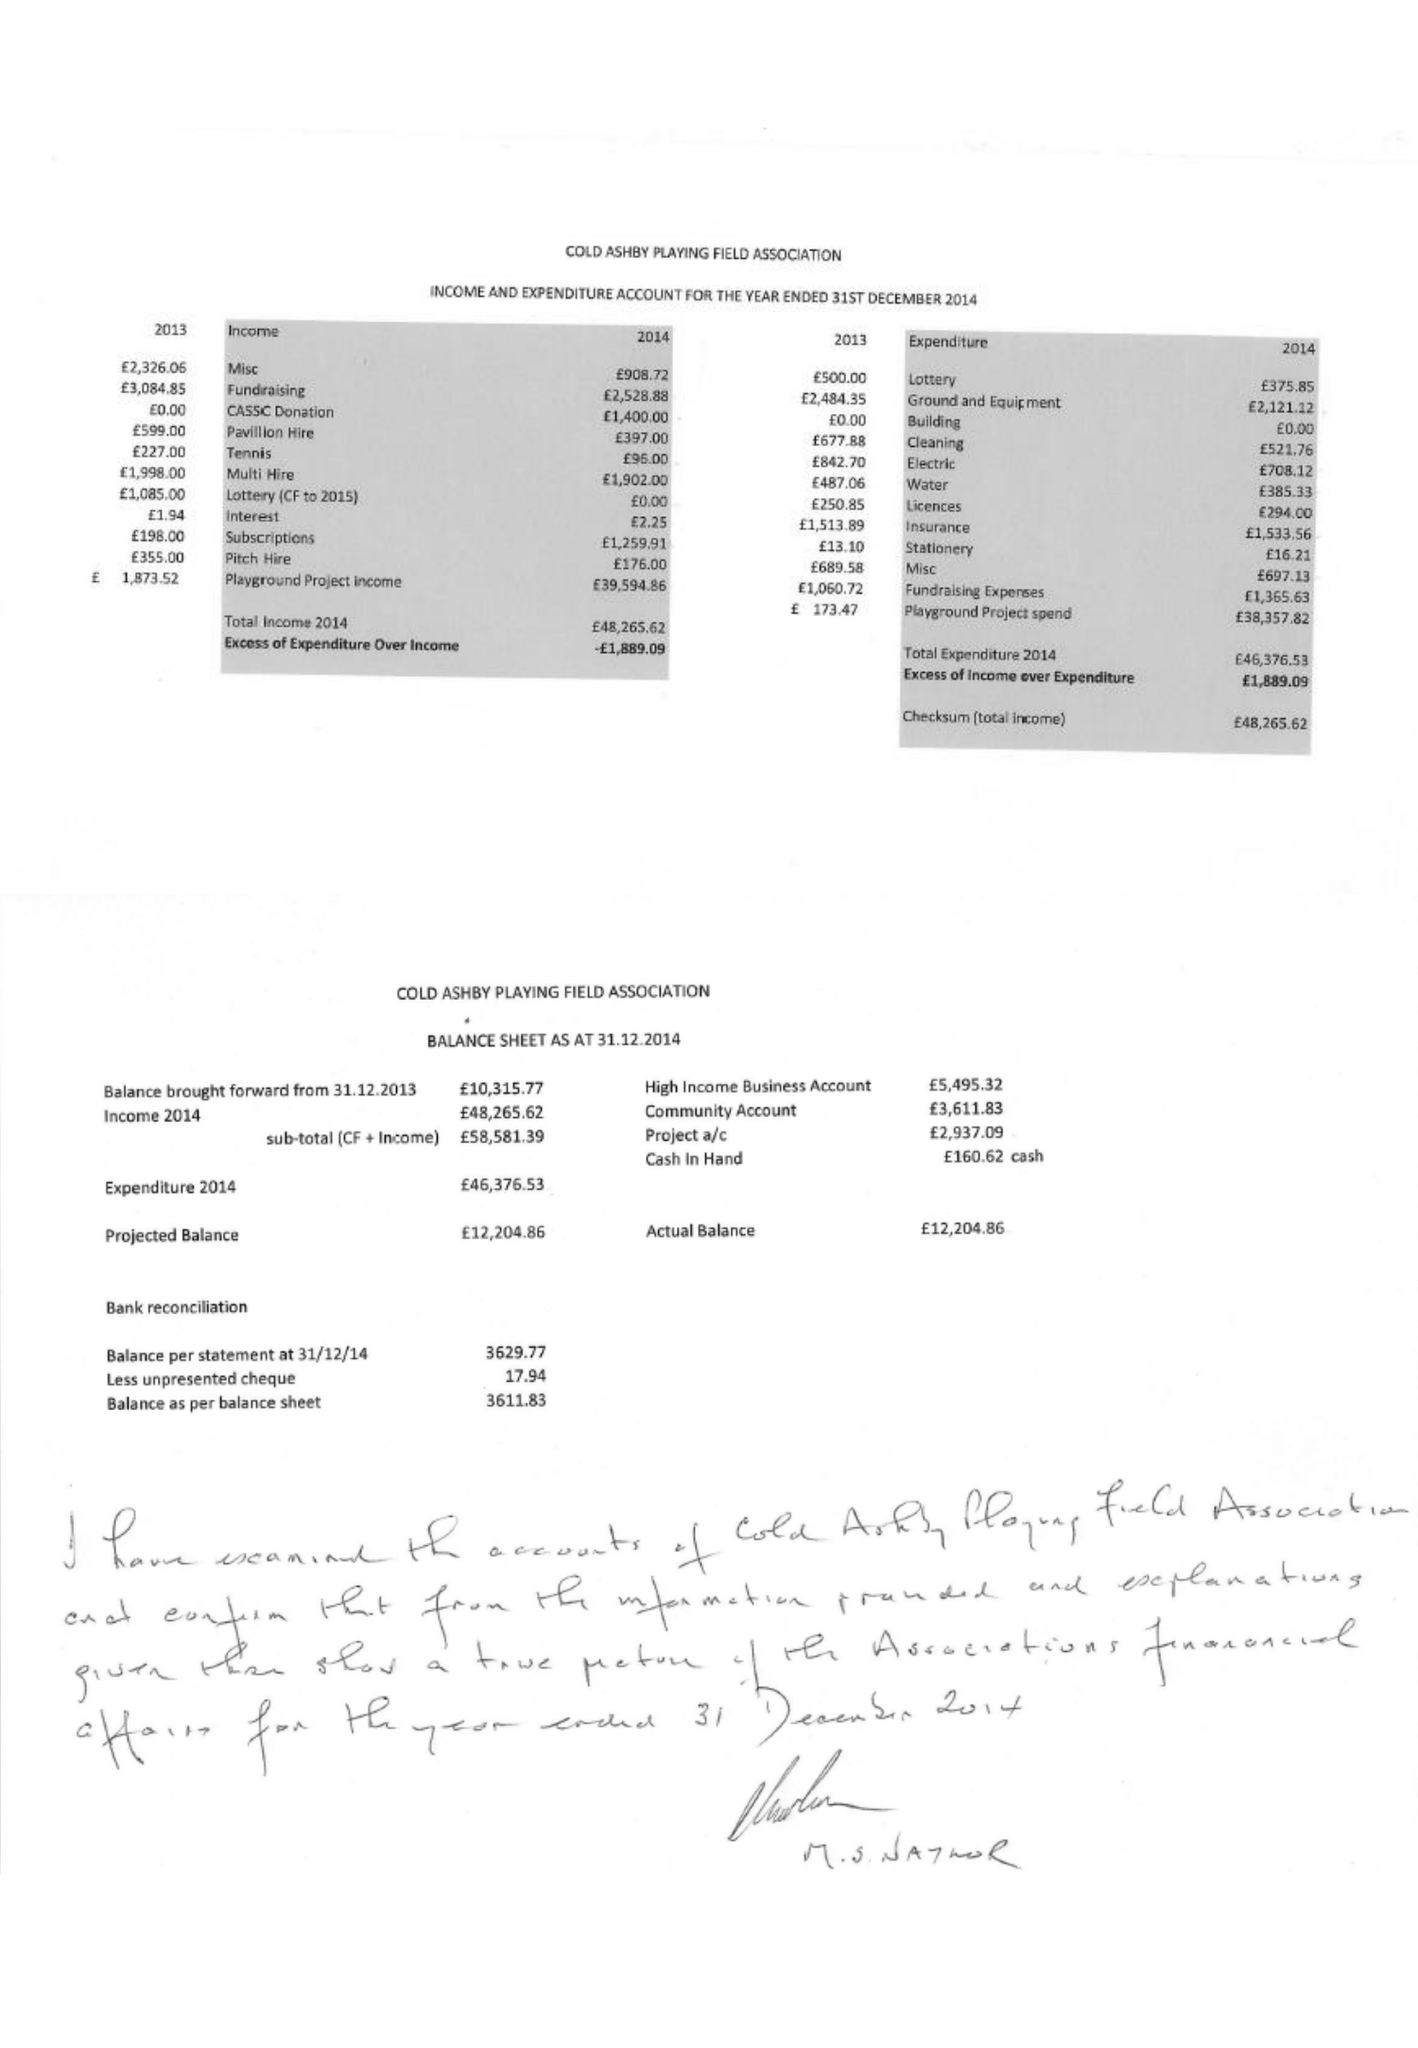What is the value for the address__street_line?
Answer the question using a single word or phrase. CRABTREE LANE 